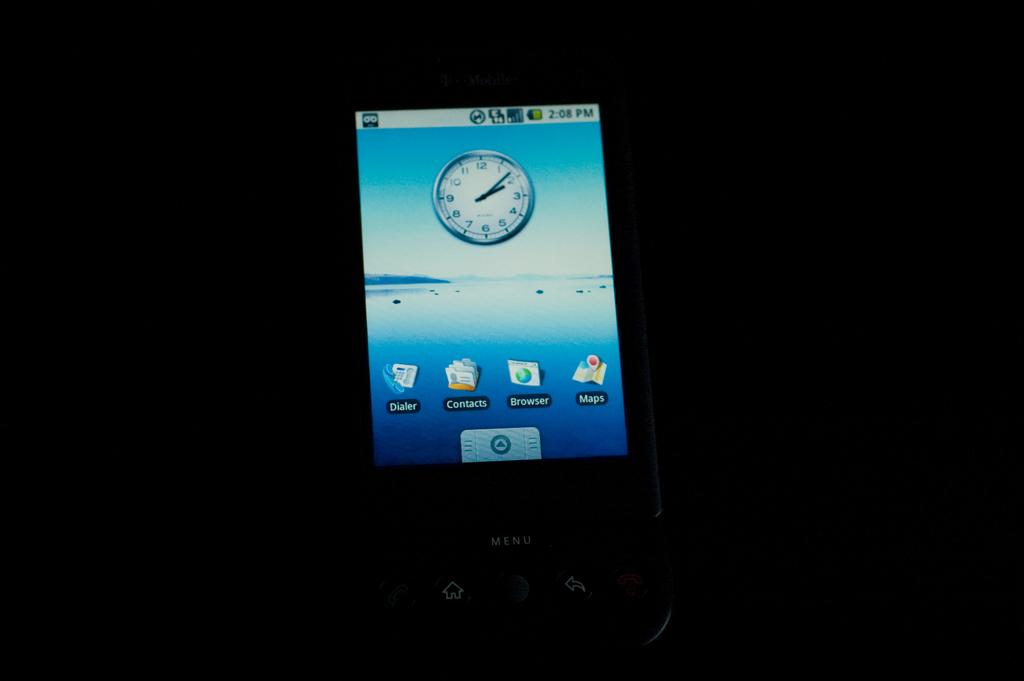Provide a one-sentence caption for the provided image. A T-Mobile cellphone displaying the time 2:08 with an analog clock.. 